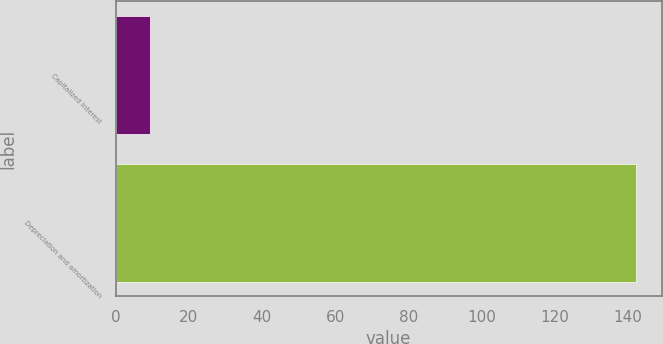Convert chart to OTSL. <chart><loc_0><loc_0><loc_500><loc_500><bar_chart><fcel>Capitalized interest<fcel>Depreciation and amortization<nl><fcel>9.5<fcel>142.1<nl></chart> 